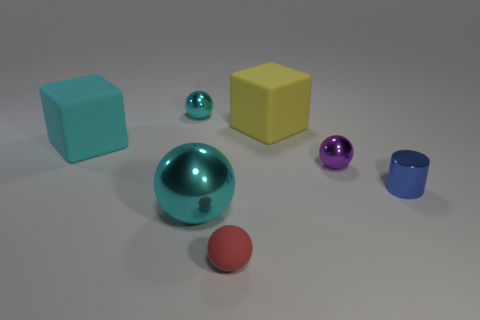Subtract all small purple metallic balls. How many balls are left? 3 Add 1 cyan objects. How many objects exist? 8 Subtract 1 cylinders. How many cylinders are left? 0 Subtract all gray blocks. How many cyan spheres are left? 2 Subtract all yellow blocks. How many blocks are left? 1 Subtract all cylinders. How many objects are left? 6 Subtract all small purple metal things. Subtract all red rubber spheres. How many objects are left? 5 Add 6 cyan spheres. How many cyan spheres are left? 8 Add 2 purple metal objects. How many purple metal objects exist? 3 Subtract 0 gray cylinders. How many objects are left? 7 